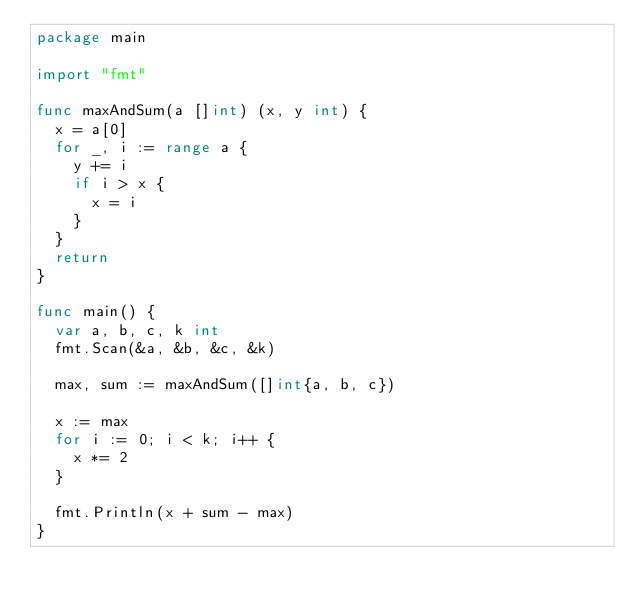Convert code to text. <code><loc_0><loc_0><loc_500><loc_500><_Go_>package main

import "fmt"

func maxAndSum(a []int) (x, y int) {
	x = a[0]
	for _, i := range a {
		y += i
		if i > x {
			x = i
		}
	}
	return
}

func main() {
	var a, b, c, k int
	fmt.Scan(&a, &b, &c, &k)

	max, sum := maxAndSum([]int{a, b, c})

	x := max
	for i := 0; i < k; i++ {
		x *= 2
	}

	fmt.Println(x + sum - max)
}
</code> 